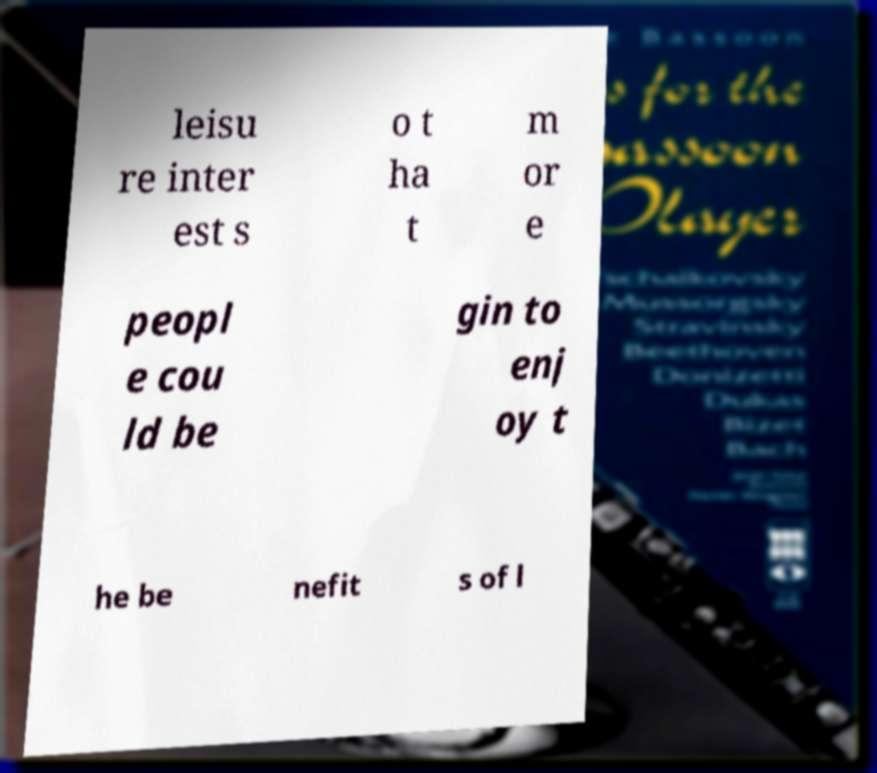There's text embedded in this image that I need extracted. Can you transcribe it verbatim? leisu re inter est s o t ha t m or e peopl e cou ld be gin to enj oy t he be nefit s of l 